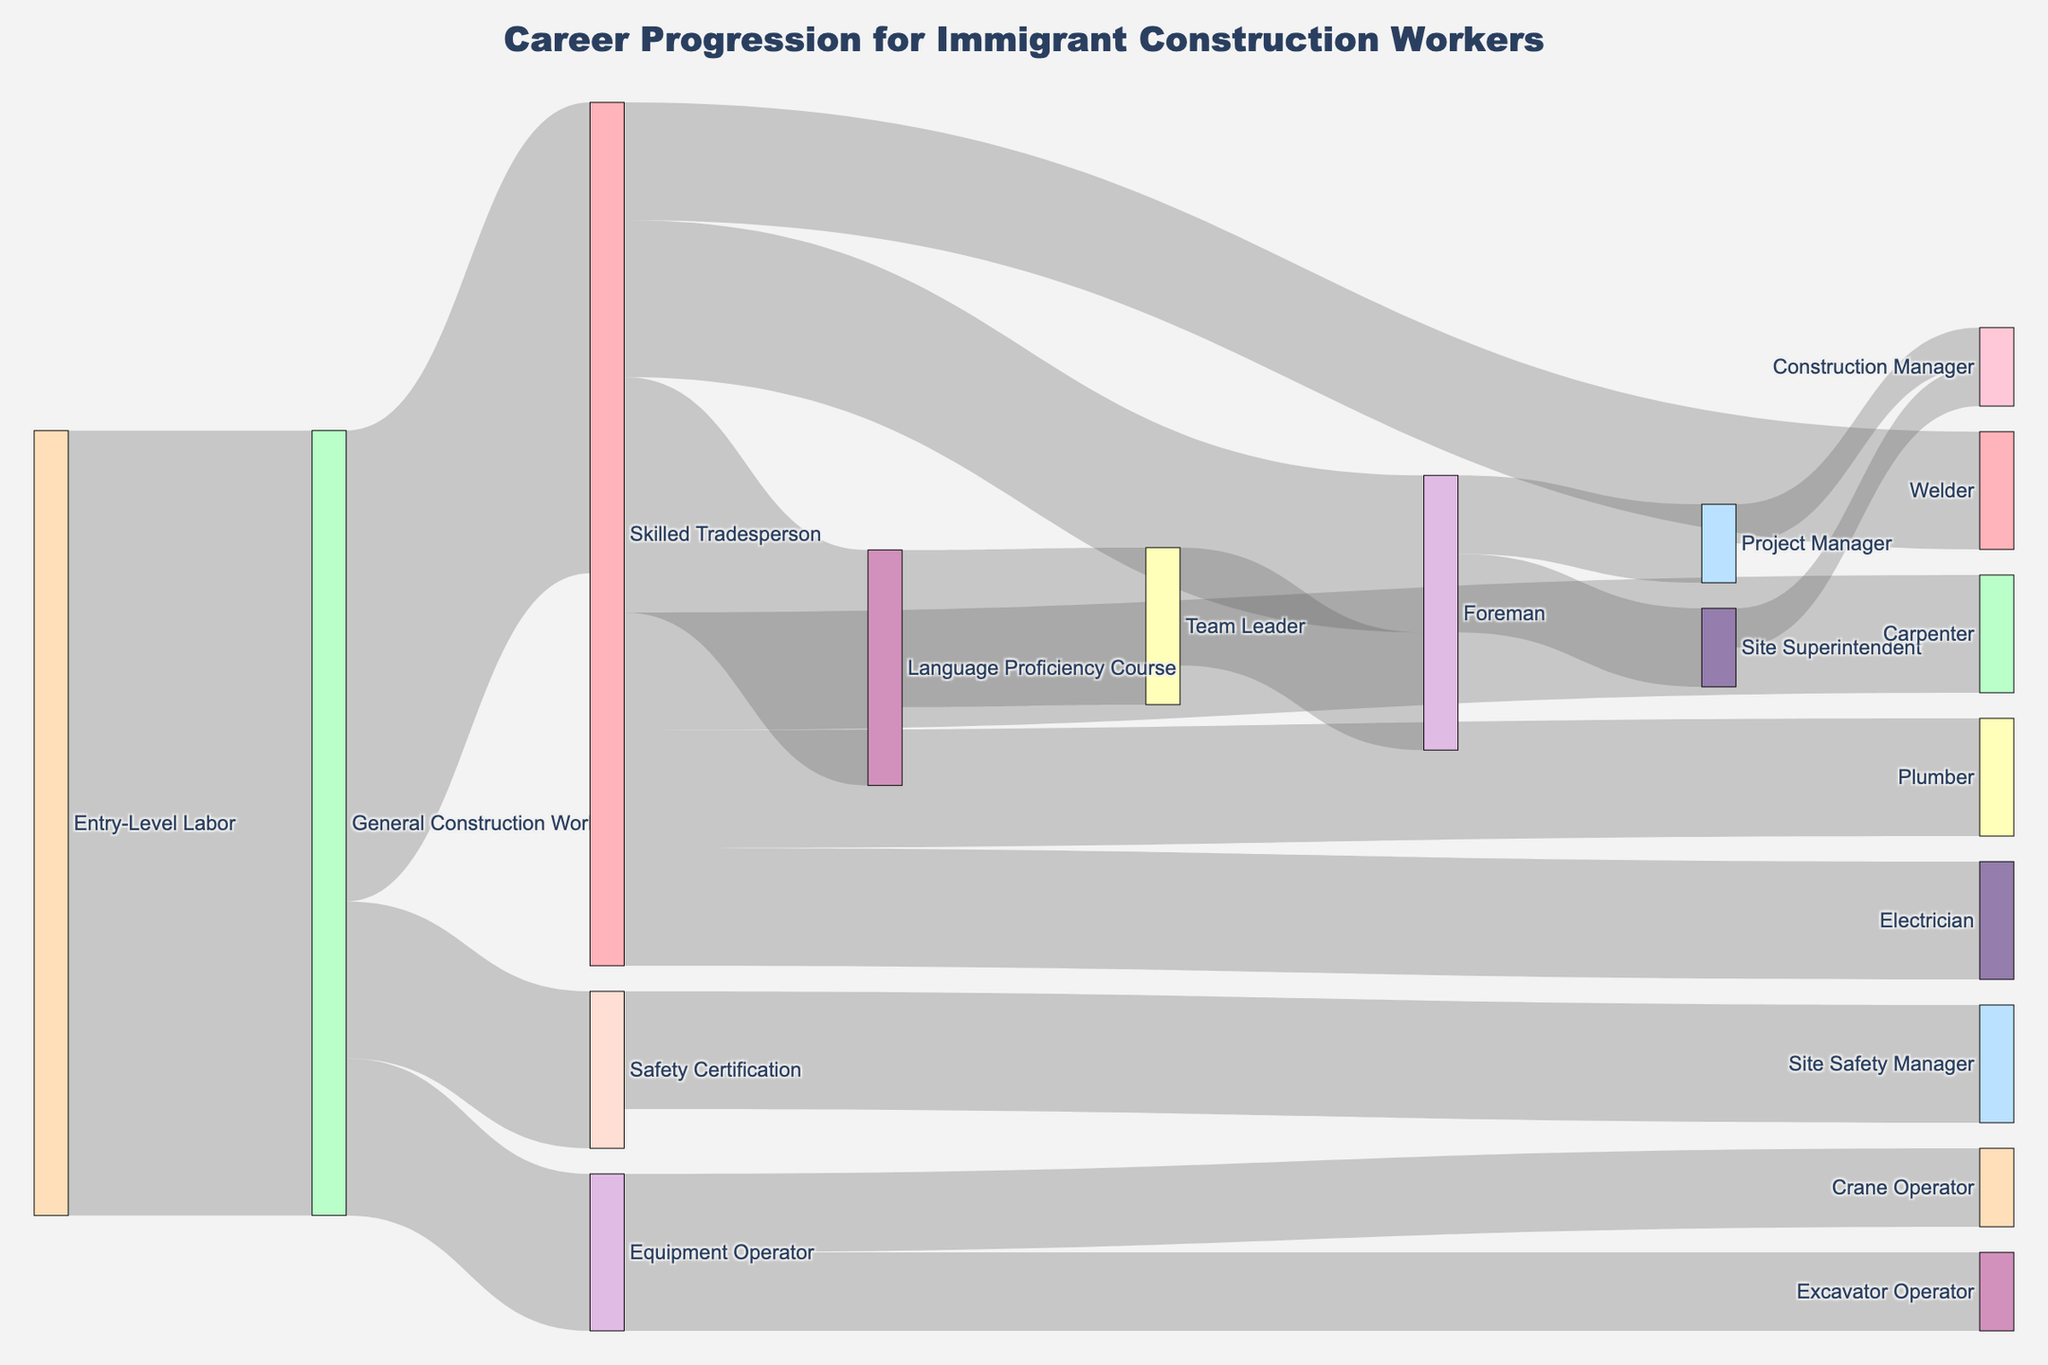How many distinct career steps are shown in the diagram? To find the number of distinct career steps, count the unique labels for all nodes in the diagram
Answer: 19 What is the first career progression step for an Entry-Level Labor worker? Locate the node labeled 'Entry-Level Labor' and follow its connection to the next node
Answer: General Construction Worker How many workers move from General Construction Worker to Skilled Tradesperson? Look at the flow label from 'General Construction Worker' to 'Skilled Tradesperson'
Answer: 60 Which career path has the higher number of workers, Skilled Tradesperson to Carpenter or Skilled Tradesperson to Language Proficiency Course? Compare the values of the two flows from Skilled Tradesperson to Carpenter (15) and Skilled Tradesperson to Language Proficiency Course (30)
Answer: Skilled Tradesperson to Language Proficiency Course What fraction of General Construction Workers move on to receive Equipment Operator training? Calculate the ratio of the value from 'General Construction Worker' to 'Equipment Operator' over the total outflow from 'General Construction Worker' (i.e., (20 / (60 + 20 + 20)) * 100)
Answer: 20% How many workers become Project Managers either directly from Foreman or through the Foreman path in another way? Sum the values of the flows from 'Foreman' to 'Project Manager' (10) and 'Team Leader' to 'Foreman' to 'Project Manager' (0 as there’s no direct path)
Answer: 10 Which path results in more workers reaching the Construction Manager role, through the Project Manager node or Site Superintendent node? Compare the values of flows leading into 'Construction Manager' from 'Project Manager' and 'Site Superintendent'
Answer: Equal (5 each) What is the total number of workers reaching the role of Foreman by any path shown? Add the values of all paths that lead to 'Foreman': from 'Skilled Tradesperson' (20) and 'Team Leader' (15)
Answer: 35 How many workers move from Safety Certification to Site Safety Manager? Check the value of the flow from 'Safety Certification' to 'Site Safety Manager'
Answer: 15 What is the total flow value from the Skilled Tradesperson node onwards? Sum all the flow values originating from 'Skilled Tradesperson': Carpenter (15), Electrician (15), Plumber (15), Welder (15), Foreman (20), and Language Proficiency Course (30)
Answer: 110 